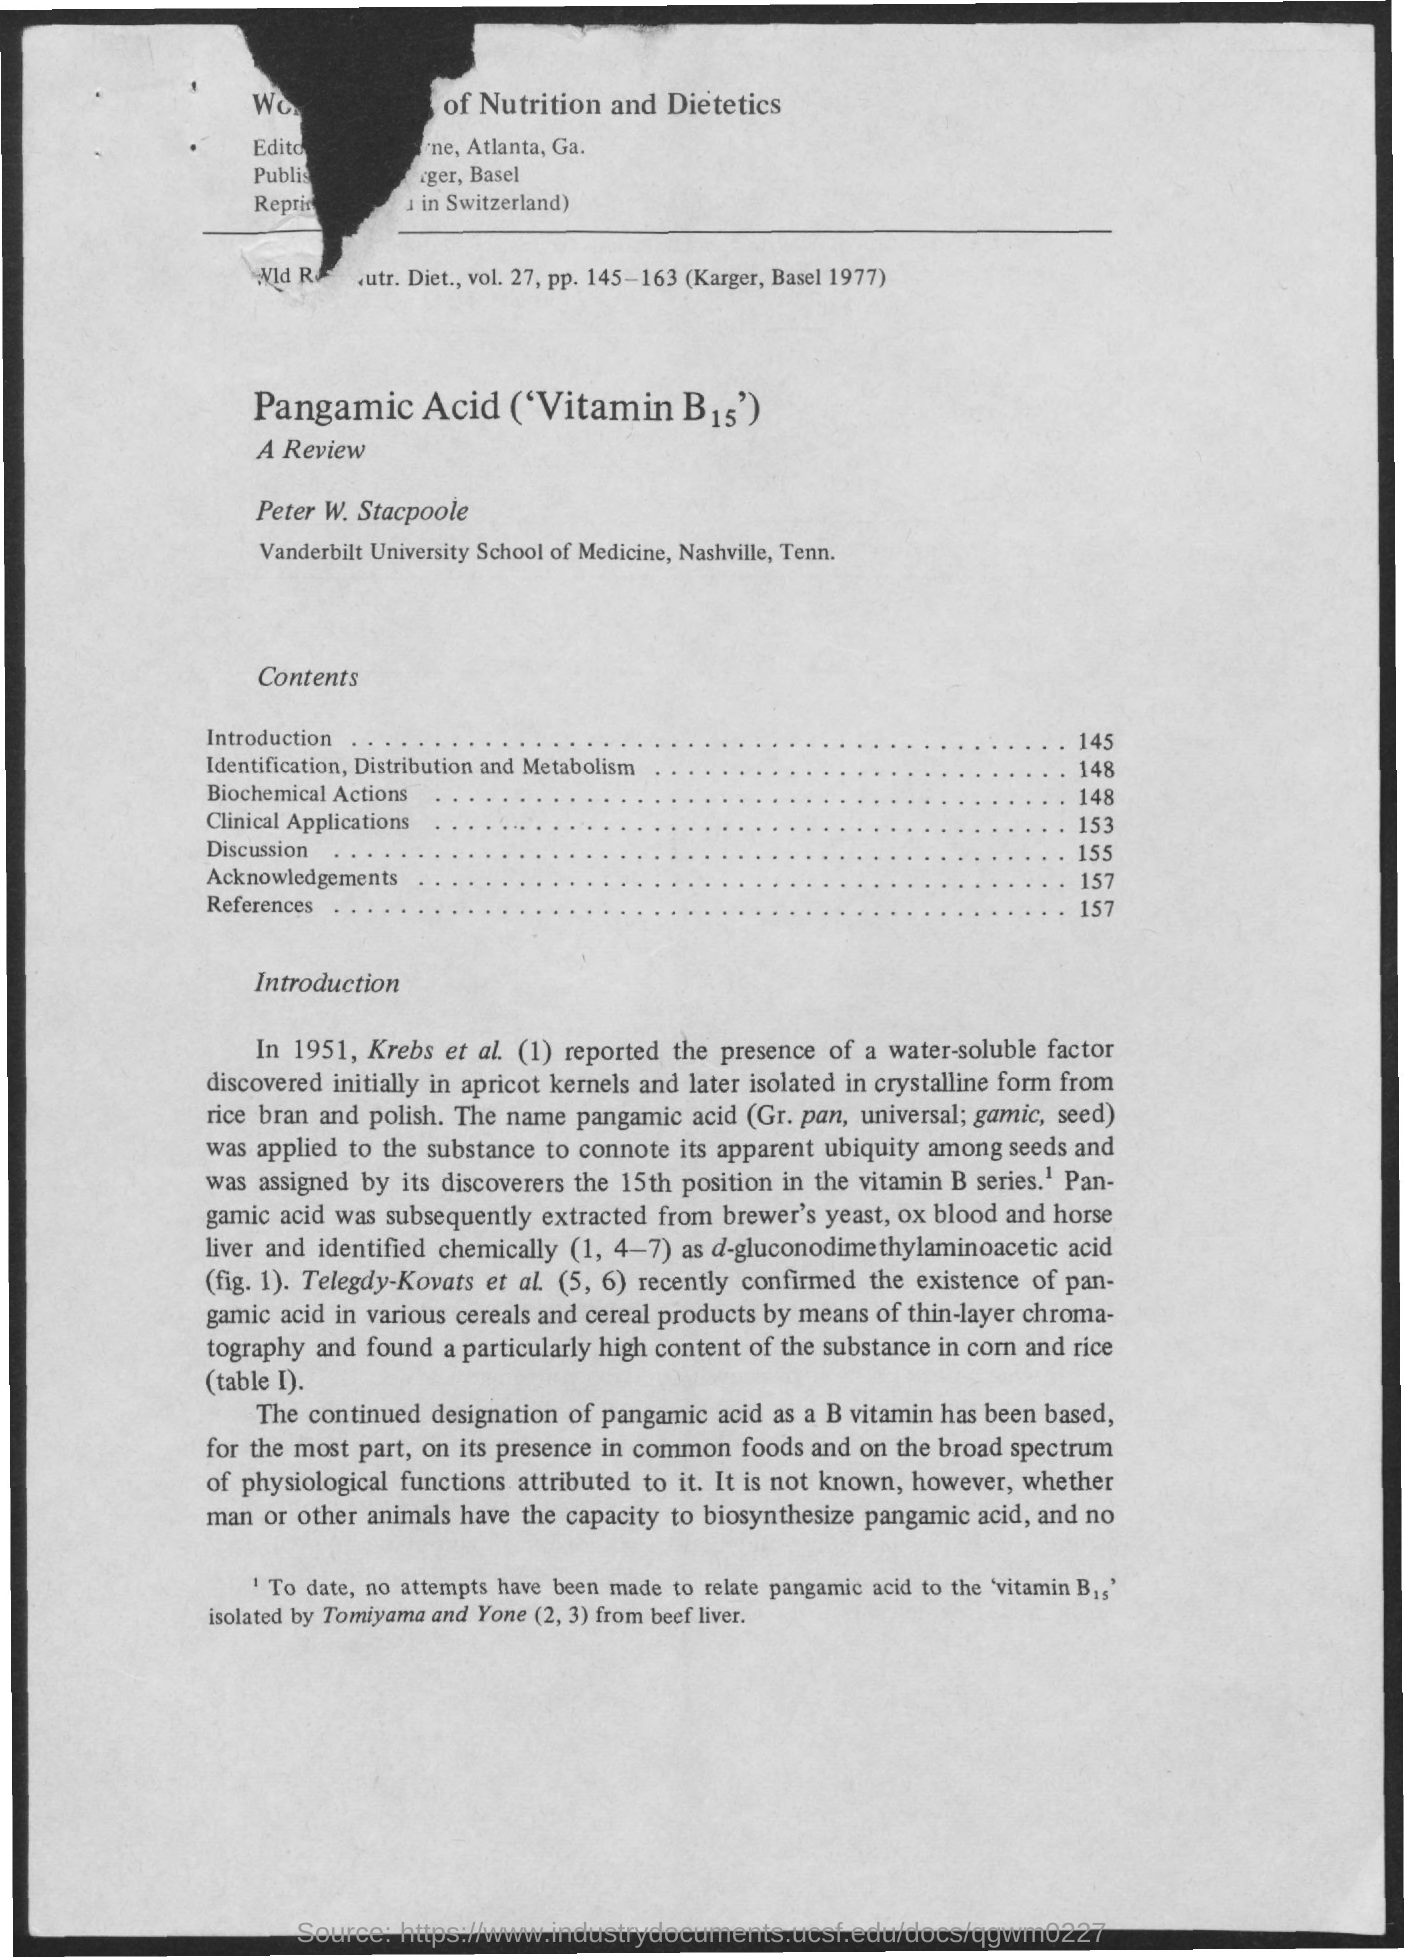What is the Page Number for Introduction?
Give a very brief answer. 145. What is the Page Number for Biochemical Actions?
Ensure brevity in your answer.  148. What is the Page Number for Discussion?
Your answer should be compact. 155. What is the Page Number for references?
Make the answer very short. 157. What is the Page Number for Acknowledgements?
Your response must be concise. 157. What is the Page Number for Clinical Applications?
Ensure brevity in your answer.  153. 